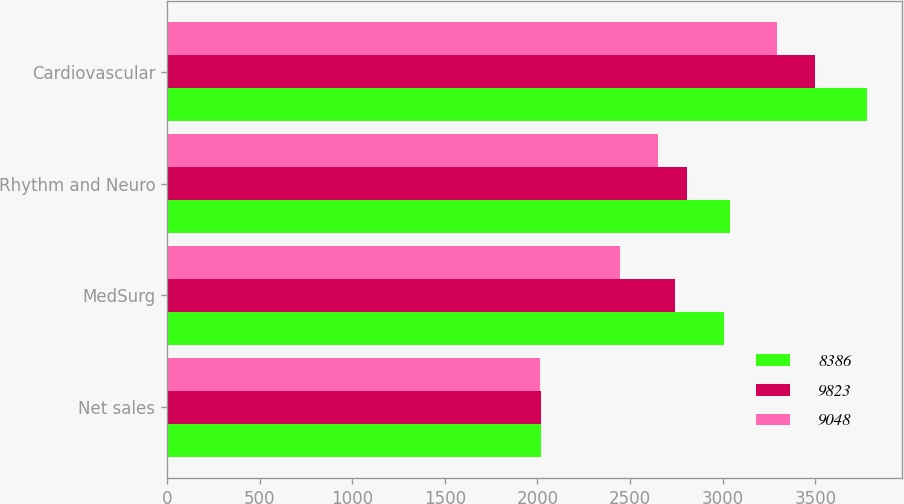Convert chart to OTSL. <chart><loc_0><loc_0><loc_500><loc_500><stacked_bar_chart><ecel><fcel>Net sales<fcel>MedSurg<fcel>Rhythm and Neuro<fcel>Cardiovascular<nl><fcel>8386<fcel>2018<fcel>3007<fcel>3041<fcel>3777<nl><fcel>9823<fcel>2017<fcel>2742<fcel>2808<fcel>3500<nl><fcel>9048<fcel>2016<fcel>2445<fcel>2649<fcel>3292<nl></chart> 